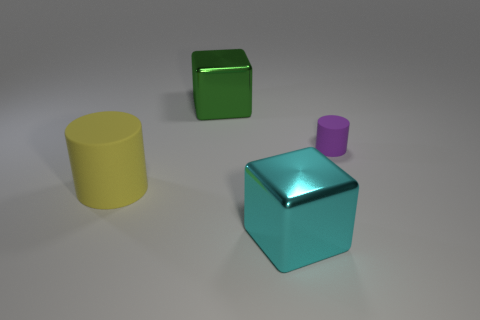Add 2 big cubes. How many objects exist? 6 Subtract 0 blue blocks. How many objects are left? 4 Subtract all metallic things. Subtract all cyan shiny objects. How many objects are left? 1 Add 2 big yellow cylinders. How many big yellow cylinders are left? 3 Add 3 blocks. How many blocks exist? 5 